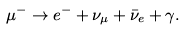<formula> <loc_0><loc_0><loc_500><loc_500>\mu ^ { - } \to e ^ { - } + \nu _ { \mu } + \bar { \nu } _ { e } + \gamma .</formula> 